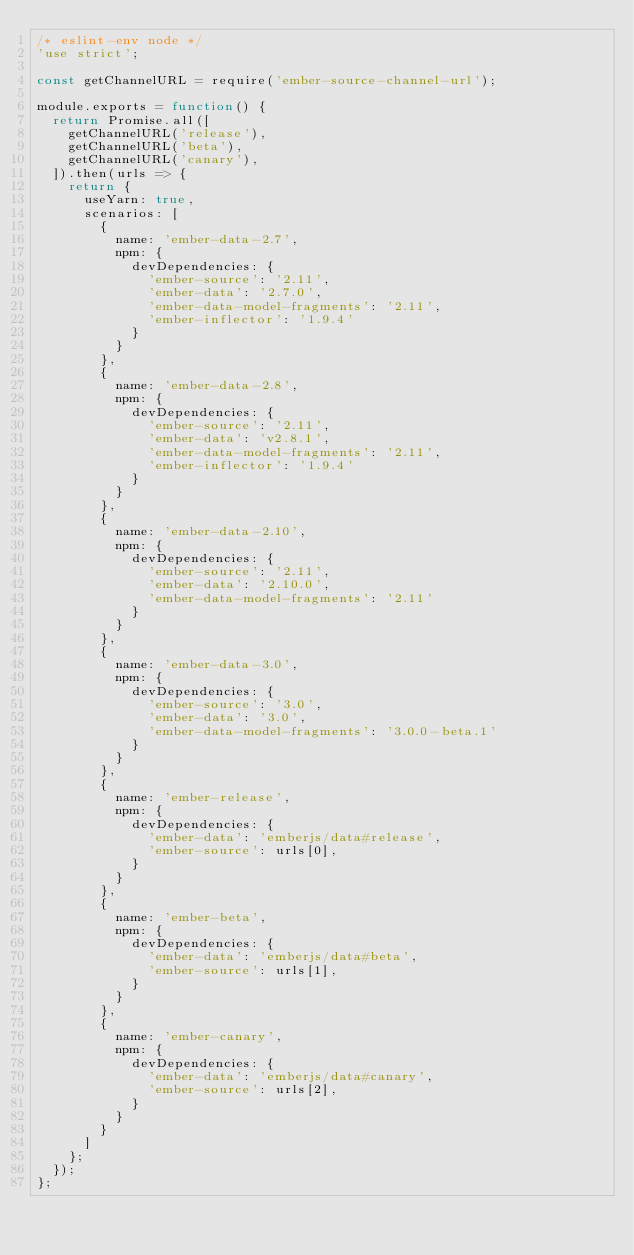Convert code to text. <code><loc_0><loc_0><loc_500><loc_500><_JavaScript_>/* eslint-env node */
'use strict';

const getChannelURL = require('ember-source-channel-url');

module.exports = function() {
  return Promise.all([
    getChannelURL('release'),
    getChannelURL('beta'),
    getChannelURL('canary'),
  ]).then(urls => {
    return {
      useYarn: true,
      scenarios: [
        {
          name: 'ember-data-2.7',
          npm: {
            devDependencies: {
              'ember-source': '2.11',
              'ember-data': '2.7.0',
              'ember-data-model-fragments': '2.11',
              'ember-inflector': '1.9.4'
            }
          }
        },
        {
          name: 'ember-data-2.8',
          npm: {
            devDependencies: {
              'ember-source': '2.11',
              'ember-data': 'v2.8.1',
              'ember-data-model-fragments': '2.11',
              'ember-inflector': '1.9.4'
            }
          }
        },
        {
          name: 'ember-data-2.10',
          npm: {
            devDependencies: {
              'ember-source': '2.11',
              'ember-data': '2.10.0',
              'ember-data-model-fragments': '2.11'
            }
          }
        },
        {
          name: 'ember-data-3.0',
          npm: {
            devDependencies: {
              'ember-source': '3.0',
              'ember-data': '3.0',
              'ember-data-model-fragments': '3.0.0-beta.1'
            }
          }
        },
        {
          name: 'ember-release',
          npm: {
            devDependencies: {
              'ember-data': 'emberjs/data#release',
              'ember-source': urls[0],
            }
          }
        },
        {
          name: 'ember-beta',
          npm: {
            devDependencies: {
              'ember-data': 'emberjs/data#beta',
              'ember-source': urls[1],
            }
          }
        },
        {
          name: 'ember-canary',
          npm: {
            devDependencies: {
              'ember-data': 'emberjs/data#canary',
              'ember-source': urls[2],
            }
          }
        }
      ]
    };
  });
};
</code> 